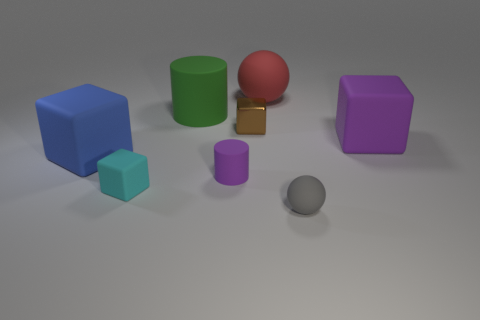Is there anything else that has the same material as the small brown cube?
Your answer should be compact. No. What is the size of the matte cube that is the same color as the small cylinder?
Make the answer very short. Large. How many other things are there of the same shape as the brown thing?
Keep it short and to the point. 3. Are there fewer rubber objects to the right of the blue object than things?
Keep it short and to the point. Yes. What is the tiny thing that is behind the blue thing made of?
Make the answer very short. Metal. What number of other objects are the same size as the red matte thing?
Make the answer very short. 3. Are there fewer green rubber things than yellow spheres?
Ensure brevity in your answer.  No. There is a small purple object; what shape is it?
Offer a very short reply. Cylinder. There is a big matte block right of the small cyan rubber object; does it have the same color as the tiny cylinder?
Offer a terse response. Yes. What is the shape of the object that is behind the tiny purple matte object and right of the large rubber ball?
Provide a succinct answer. Cube. 